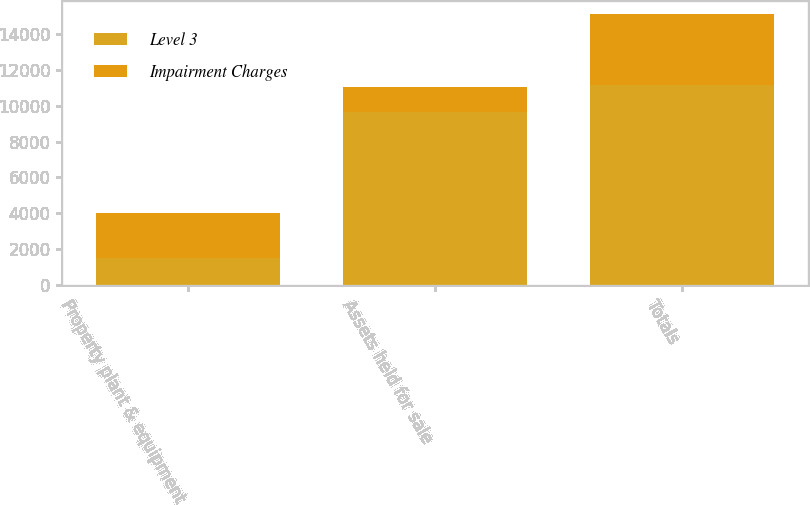<chart> <loc_0><loc_0><loc_500><loc_500><stacked_bar_chart><ecel><fcel>Property plant & equipment<fcel>Assets held for sale<fcel>Totals<nl><fcel>Level 3<fcel>1536<fcel>9625<fcel>11161<nl><fcel>Impairment Charges<fcel>2500<fcel>1436<fcel>3936<nl></chart> 